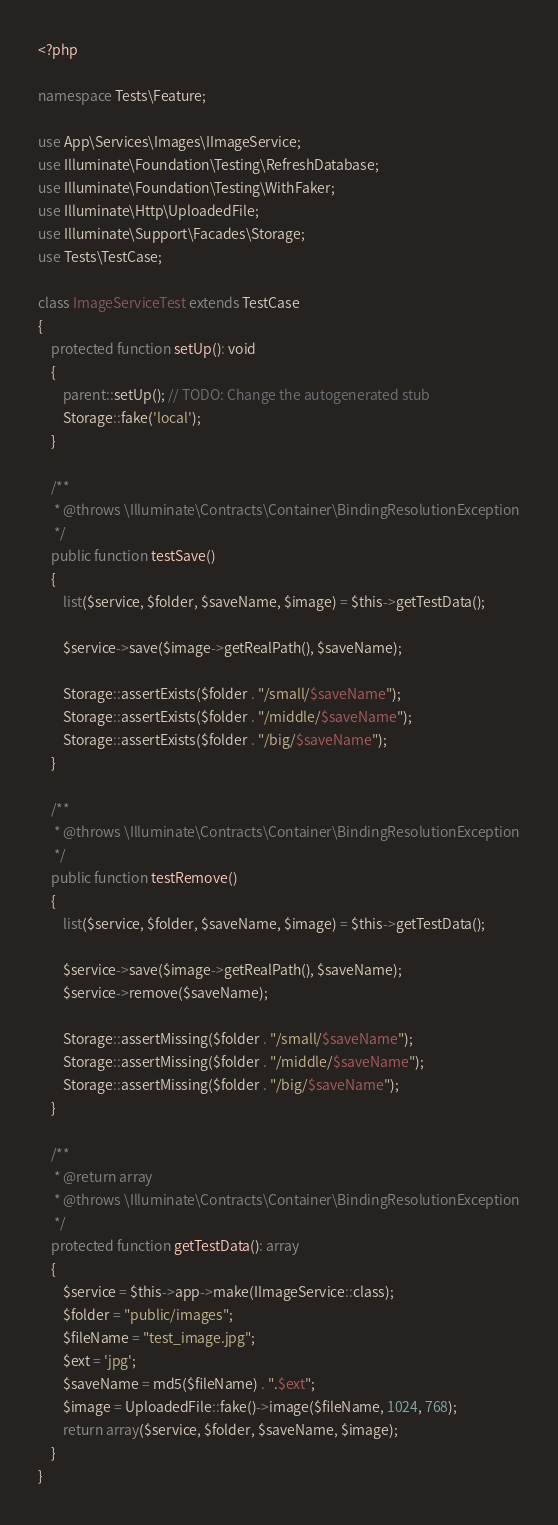<code> <loc_0><loc_0><loc_500><loc_500><_PHP_><?php

namespace Tests\Feature;

use App\Services\Images\IImageService;
use Illuminate\Foundation\Testing\RefreshDatabase;
use Illuminate\Foundation\Testing\WithFaker;
use Illuminate\Http\UploadedFile;
use Illuminate\Support\Facades\Storage;
use Tests\TestCase;

class ImageServiceTest extends TestCase
{
    protected function setUp(): void
    {
        parent::setUp(); // TODO: Change the autogenerated stub
        Storage::fake('local');
    }

    /**
     * @throws \Illuminate\Contracts\Container\BindingResolutionException
     */
    public function testSave()
    {
        list($service, $folder, $saveName, $image) = $this->getTestData();

        $service->save($image->getRealPath(), $saveName);

        Storage::assertExists($folder . "/small/$saveName");
        Storage::assertExists($folder . "/middle/$saveName");
        Storage::assertExists($folder . "/big/$saveName");
    }

    /**
     * @throws \Illuminate\Contracts\Container\BindingResolutionException
     */
    public function testRemove()
    {
        list($service, $folder, $saveName, $image) = $this->getTestData();

        $service->save($image->getRealPath(), $saveName);
        $service->remove($saveName);

        Storage::assertMissing($folder . "/small/$saveName");
        Storage::assertMissing($folder . "/middle/$saveName");
        Storage::assertMissing($folder . "/big/$saveName");
    }

    /**
     * @return array
     * @throws \Illuminate\Contracts\Container\BindingResolutionException
     */
    protected function getTestData(): array
    {
        $service = $this->app->make(IImageService::class);
        $folder = "public/images";
        $fileName = "test_image.jpg";
        $ext = 'jpg';
        $saveName = md5($fileName) . ".$ext";
        $image = UploadedFile::fake()->image($fileName, 1024, 768);
        return array($service, $folder, $saveName, $image);
    }
}
</code> 